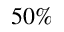Convert formula to latex. <formula><loc_0><loc_0><loc_500><loc_500>5 0 \%</formula> 